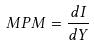<formula> <loc_0><loc_0><loc_500><loc_500>M P M = \frac { d I } { d Y }</formula> 